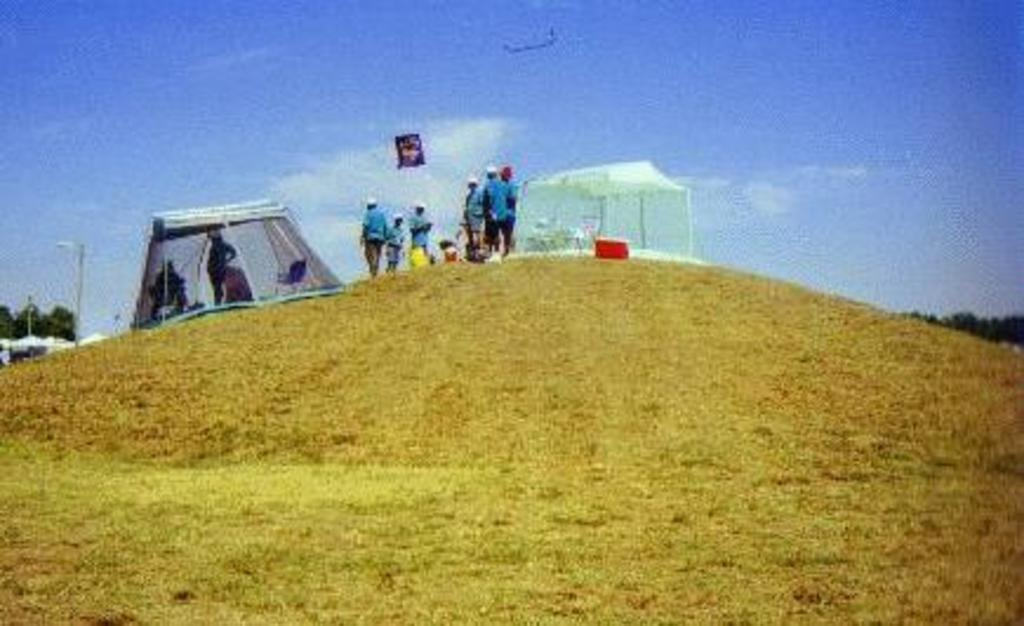How many people are present in the image? There are many people standing in the image. What are the people wearing? The people are wearing clothes and caps. What type of ground surface is visible in the image? There is grass in the image. Can you describe any structures or objects in the image? There is a light pole, a tree, a tent, and a box in the image. What is the weather like in the image? The sky is cloudy in the image. What type of pickle is being used as a hat by one of the people in the image? There is no pickle present in the image, and no one is wearing a pickle as a hat. 